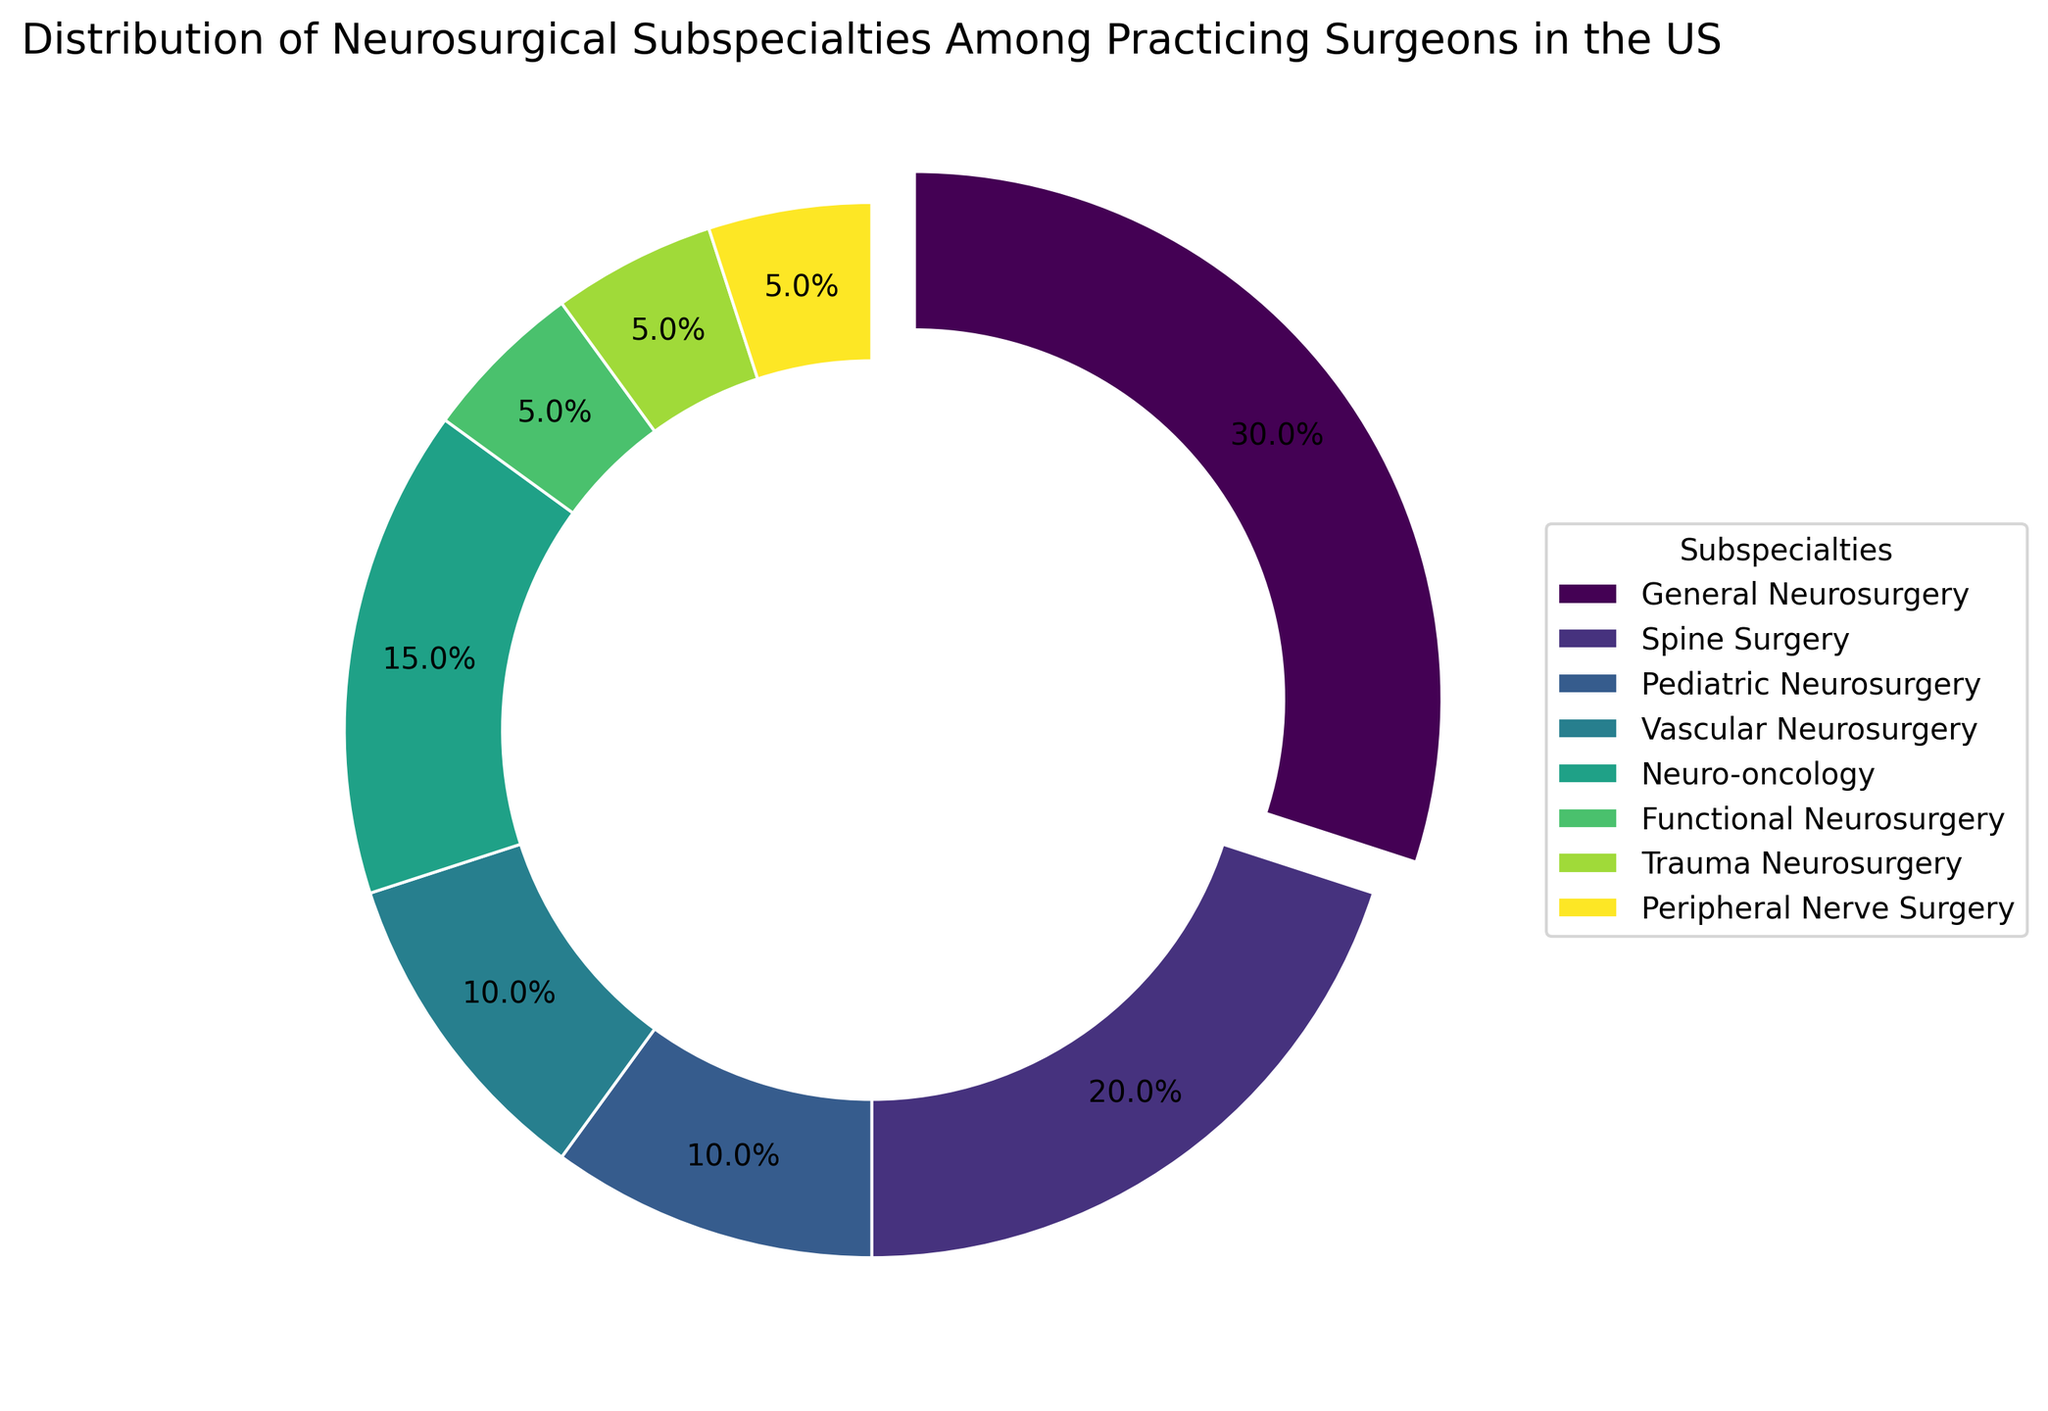Which neurosurgical subspecialty has the largest percentage of practicing surgeons? The segment with the largest percentage is exploded out from the ring, which helps to identify it quickly as General Neurosurgery with 30%.
Answer: General Neurosurgery Which two subspecialties have the same percentage of practicing surgeons? By examining the sizes and percentages of each segment, it is evident that Trauma Neurosurgery, Functional Neurosurgery, and Peripheral Nerve Surgery each have 5%. Any pair among these three will have the same percentage.
Answer: Trauma Neurosurgery and Functional Neurosurgery (or any pair among the three) How much larger is the percentage of Spine Surgery compared to Pediatric Neurosurgery? Spine Surgery has 20%, while Pediatric Neurosurgery has 10%. The difference is 20% - 10% = 10%.
Answer: 10% What is the combined percentage of surgeons specializing in Vascular Neurosurgery and Neuro-oncology? Vascular Neurosurgery is 10% and Neuro-oncology is 15%. Their combined percentage is 10% + 15% = 25%.
Answer: 25% How much smaller is the percentage of Pediatric Neurosurgery compared to General Neurosurgery? General Neurosurgery is 30%, while Pediatric Neurosurgery is 10%. The difference is 30% - 10% = 20%.
Answer: 20% Which subspecialty is represented using the darkest color? By examining the color gradient from light to dark, the segment with the darkest color is General Neurosurgery, which also has the largest percentage.
Answer: General Neurosurgery Are there more surgeons specializing in Spine Surgery or in Neuro-oncology? Spine Surgery has a 20% share while Neuro-oncology has 15%. Comparing these values shows that there are more surgeons in Spine Surgery.
Answer: Spine Surgery Which subspecialty has the smallest percentage of practicing surgeons, excluding those that have the same smallest percentage? Functional Neurosurgery, Trauma Neurosurgery, and Peripheral Nerve Surgery each have 5%. Since they share the same smallest percentage, there is no single subspecialty with the smallest percentage when they all are considered.
Answer: Functional Neurosurgery, Trauma Neurosurgery, and Peripheral Nerve Surgery What is the difference between the percentages of surgeons in Pediatric Neurosurgery and Vascular Neurosurgery? Both Pediatric Neurosurgery and Vascular Neurosurgery have the same percentage of 10%. The difference, therefore, is 10% - 10% = 0%.
Answer: 0% How many subspecialties have a percentage of 10% or more? General Neurosurgery (30%), Spine Surgery (20%), Pediatric Neurosurgery (10%), Vascular Neurosurgery (10%), and Neuro-oncology (15%) each have percentages of 10% or more. Counting these gives a total of 5 subspecialties.
Answer: 5 